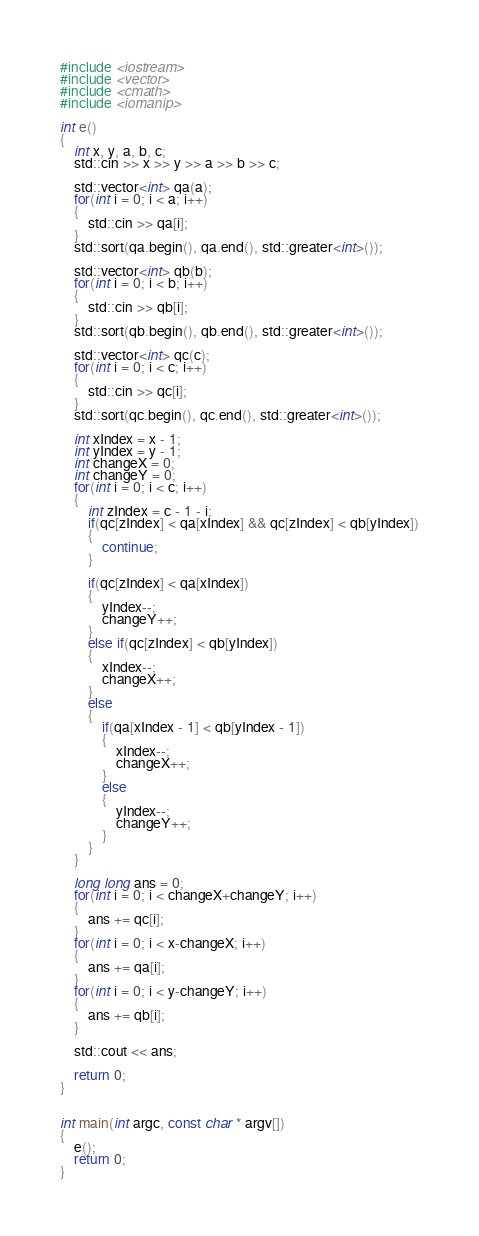Convert code to text. <code><loc_0><loc_0><loc_500><loc_500><_C++_>#include <iostream>
#include <vector>
#include <cmath>
#include <iomanip>

int e()
{
    int x, y, a, b, c;
    std::cin >> x >> y >> a >> b >> c;
    
    std::vector<int> qa(a);
    for(int i = 0; i < a; i++)
    {
        std::cin >> qa[i];
    }
    std::sort(qa.begin(), qa.end(), std::greater<int>());
    
    std::vector<int> qb(b);
    for(int i = 0; i < b; i++)
    {
        std::cin >> qb[i];
    }
    std::sort(qb.begin(), qb.end(), std::greater<int>());
    
    std::vector<int> qc(c);
    for(int i = 0; i < c; i++)
    {
        std::cin >> qc[i];
    }
    std::sort(qc.begin(), qc.end(), std::greater<int>());
    
    int xIndex = x - 1;
    int yIndex = y - 1;
    int changeX = 0;
    int changeY = 0;
    for(int i = 0; i < c; i++)
    {
        int zIndex = c - 1 - i;
        if(qc[zIndex] < qa[xIndex] && qc[zIndex] < qb[yIndex])
        {
            continue;
        }
        
        if(qc[zIndex] < qa[xIndex])
        {
            yIndex--;
            changeY++;
        }
        else if(qc[zIndex] < qb[yIndex])
        {
            xIndex--;
            changeX++;
        }
        else
        {
            if(qa[xIndex - 1] < qb[yIndex - 1])
            {
                xIndex--;
                changeX++;
            }
            else
            {
                yIndex--;
                changeY++;
            }
        }
    }
    
    long long ans = 0;
    for(int i = 0; i < changeX+changeY; i++)
    {
        ans += qc[i];
    }
    for(int i = 0; i < x-changeX; i++)
    {
        ans += qa[i];
    }
    for(int i = 0; i < y-changeY; i++)
    {
        ans += qb[i];
    }
    
    std::cout << ans;
    
    return 0;
}


int main(int argc, const char * argv[])
{
    e();
    return 0;
}</code> 